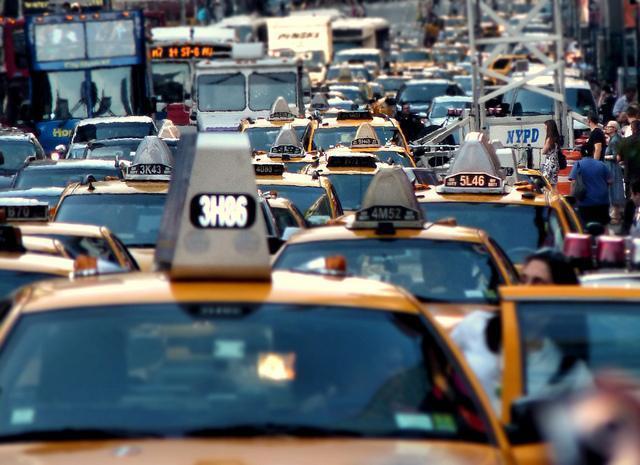What is happening on the road?
Select the accurate response from the four choices given to answer the question.
Options: Protest, parade, traffic jam, car accident. Traffic jam. 